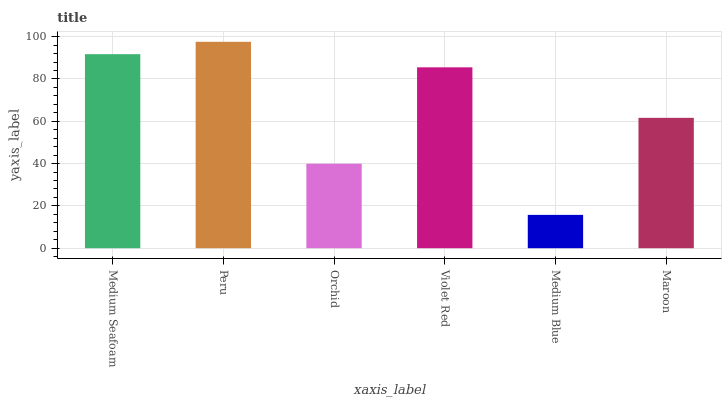Is Medium Blue the minimum?
Answer yes or no. Yes. Is Peru the maximum?
Answer yes or no. Yes. Is Orchid the minimum?
Answer yes or no. No. Is Orchid the maximum?
Answer yes or no. No. Is Peru greater than Orchid?
Answer yes or no. Yes. Is Orchid less than Peru?
Answer yes or no. Yes. Is Orchid greater than Peru?
Answer yes or no. No. Is Peru less than Orchid?
Answer yes or no. No. Is Violet Red the high median?
Answer yes or no. Yes. Is Maroon the low median?
Answer yes or no. Yes. Is Peru the high median?
Answer yes or no. No. Is Orchid the low median?
Answer yes or no. No. 